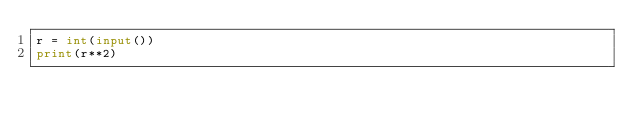<code> <loc_0><loc_0><loc_500><loc_500><_Python_>r = int(input())
print(r**2)
</code> 